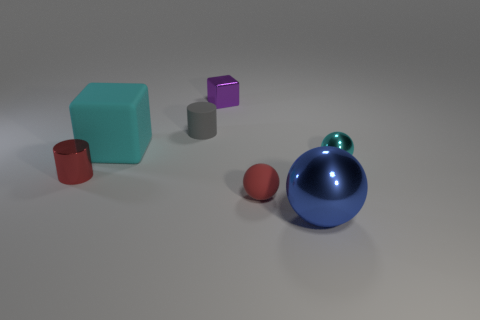Subtract all blue spheres. How many spheres are left? 2 Add 2 rubber things. How many objects exist? 9 Subtract all red cylinders. How many cylinders are left? 1 Subtract 1 red balls. How many objects are left? 6 Subtract all spheres. How many objects are left? 4 Subtract 1 blocks. How many blocks are left? 1 Subtract all purple blocks. Subtract all brown cylinders. How many blocks are left? 1 Subtract all tiny metallic cubes. Subtract all small red things. How many objects are left? 4 Add 1 tiny gray things. How many tiny gray things are left? 2 Add 4 large rubber cubes. How many large rubber cubes exist? 5 